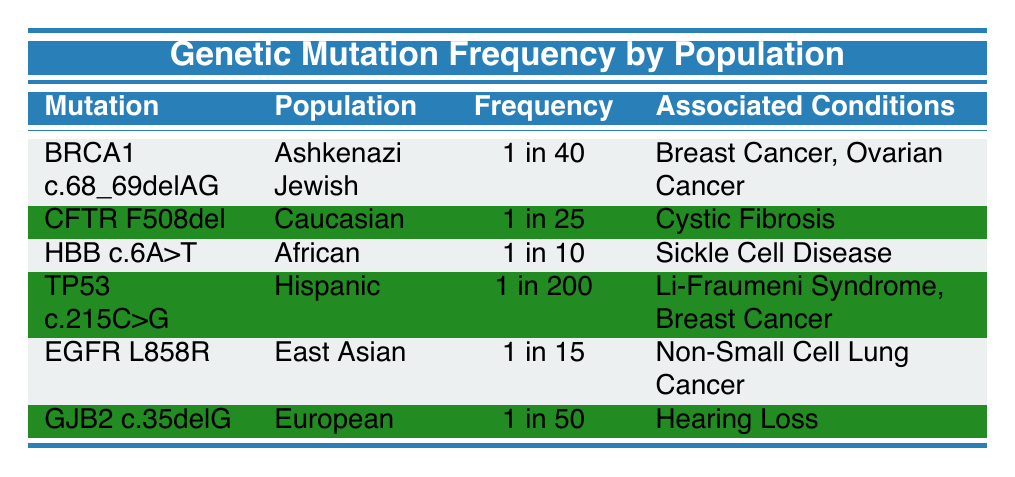What mutation has the highest frequency in the table? The frequencies listed are: BRCA1 c.68_69delAG (1 in 40), CFTR F508del (1 in 25), HBB c.6A>T (1 in 10), TP53 c.215C>G (1 in 200), EGFR L858R (1 in 15), GJB2 c.35delG (1 in 50). Comparing these, the mutation with the highest frequency is CFTR F508del which has a frequency of 1 in 25.
Answer: CFTR F508del Which population has the lowest frequency of mutations? The frequencies provided are: Ashkenazi Jewish (1 in 40), Caucasian (1 in 25), African (1 in 10), Hispanic (1 in 200), East Asian (1 in 15), European (1 in 50). The lowest frequency in this list is 1 in 200 for the Hispanic population.
Answer: Hispanic Are there any mutations associated with Breast Cancer? The mutations associated with Breast Cancer are BRCA1 c.68_69delAG and TP53 c.215C>G. Thus, the answer is yes; both mutations are associated with Breast Cancer.
Answer: Yes How many mutations are associated with hearing loss? From the table, GJB2 c.35delG is the only mutation listed that is associated with hearing loss. Therefore, there is only one mutation with this association.
Answer: 1 What is the average frequency of mutations for the populations listed? The frequencies can be converted to ratios: BRCA1 c.68_69delAG (1/40), CFTR F508del (1/25), HBB c.6A>T (1/10), TP53 c.215C>G (1/200), EGFR L858R (1/15), GJB2 c.35delG (1/50). First, convert them all to a common fraction: 1/10 = 10, 1/15 = 15.33, 1/25 = 25, 1/40 = 40, 1/50 = 50, and 1/200 = 200. Summing these gives 10 + 15.33 + 25 + 40 + 50 + 200 = 340. There are 6 data points, so the average is 340/6 = approximately 56.67.
Answer: 56.67 Is the EGFR L858R mutation present in the Caucasian population? The EGFR L858R mutation is specifically listed under the East Asian population. Since the Caucasian population has the CFTR F508del mutation, EGFR L858R is not present in the Caucasian population. Thus, the answer is no.
Answer: No 